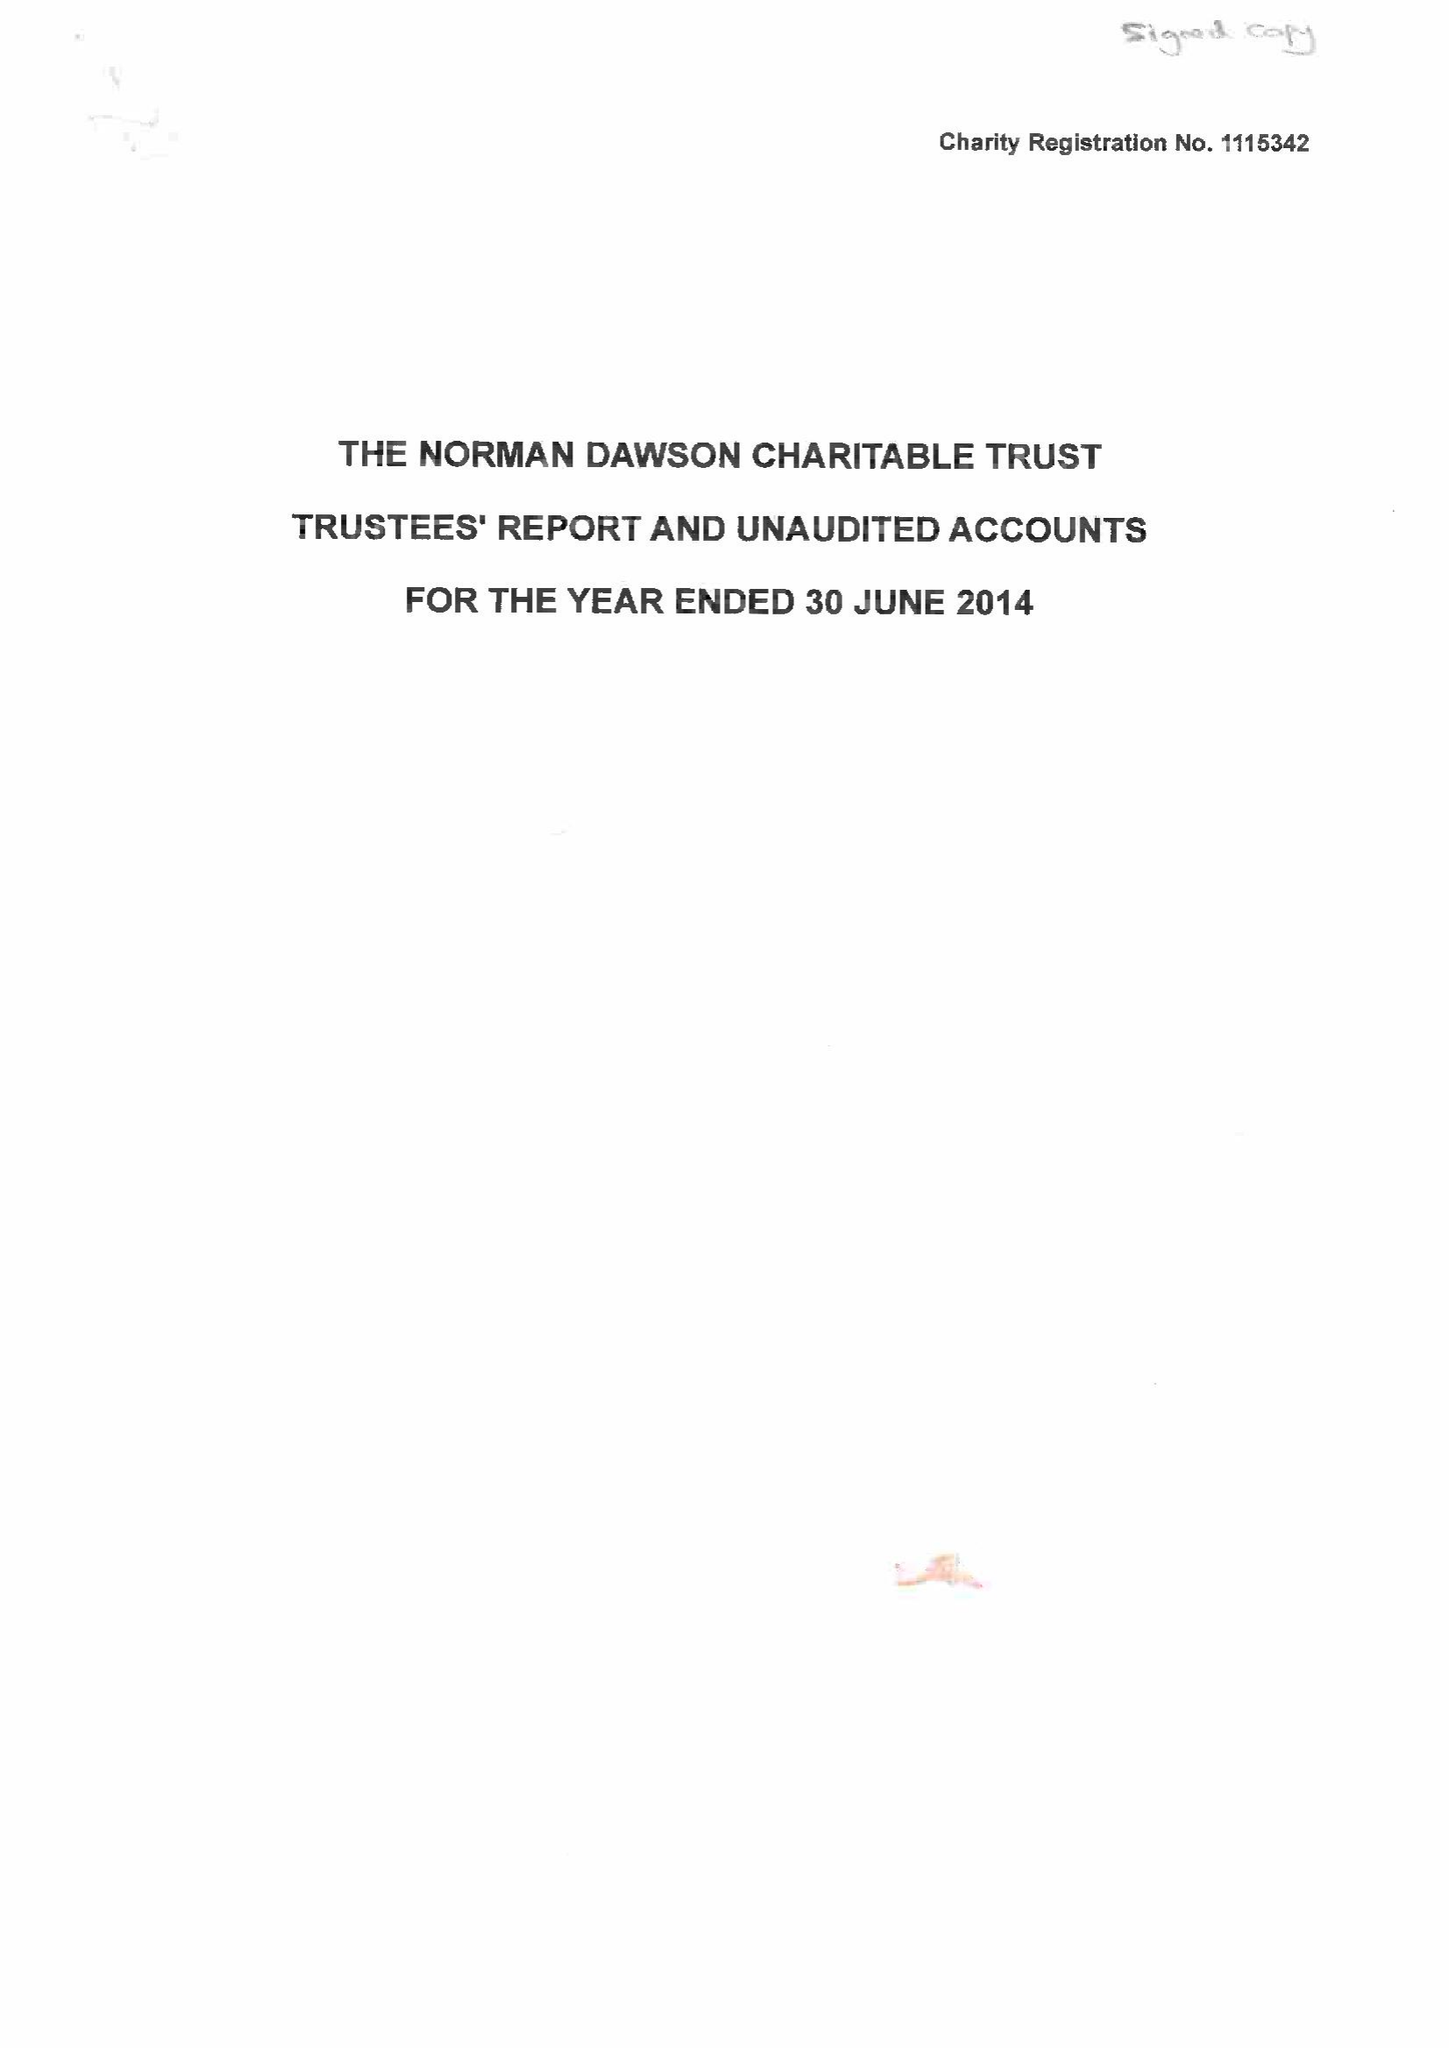What is the value for the address__street_line?
Answer the question using a single word or phrase. BIRMINGHAM ROAD 